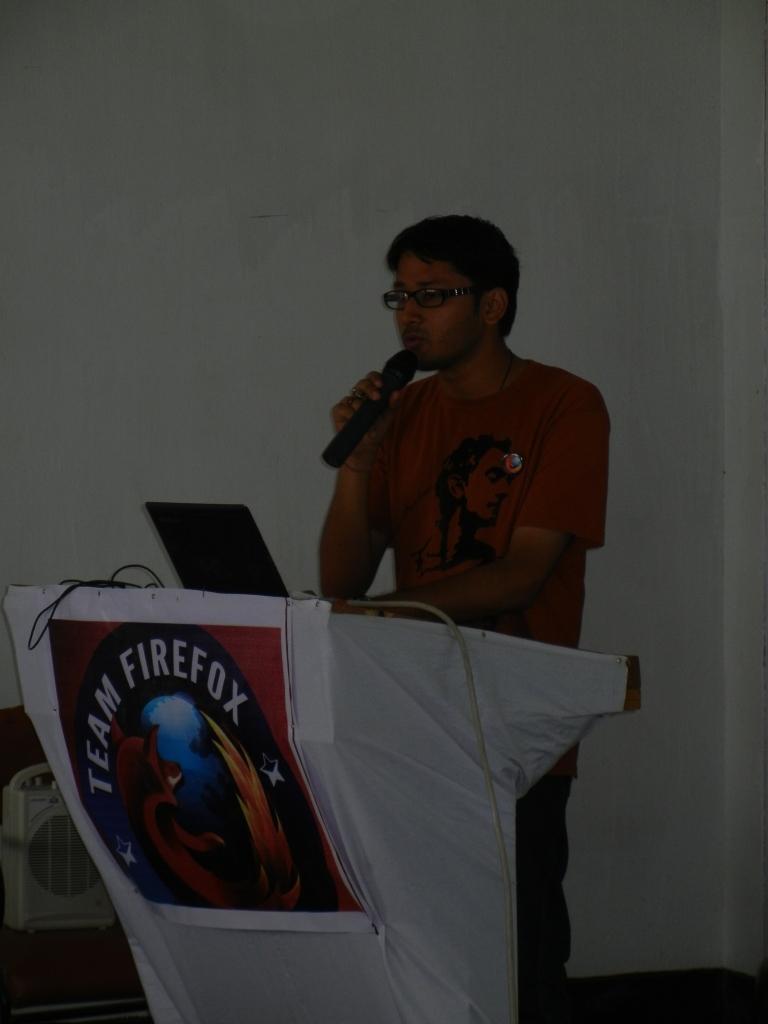Could you give a brief overview of what you see in this image? This image is taken indoors. In the background there is a wall. At the bottom of the image. There is a floor. In the middle of the image there is a podium with laptop and a mic on it. There is a board with a text on it. A boy is standing and talking. He is holding a mic in his hand. On the left side of the image there is a cooler. 